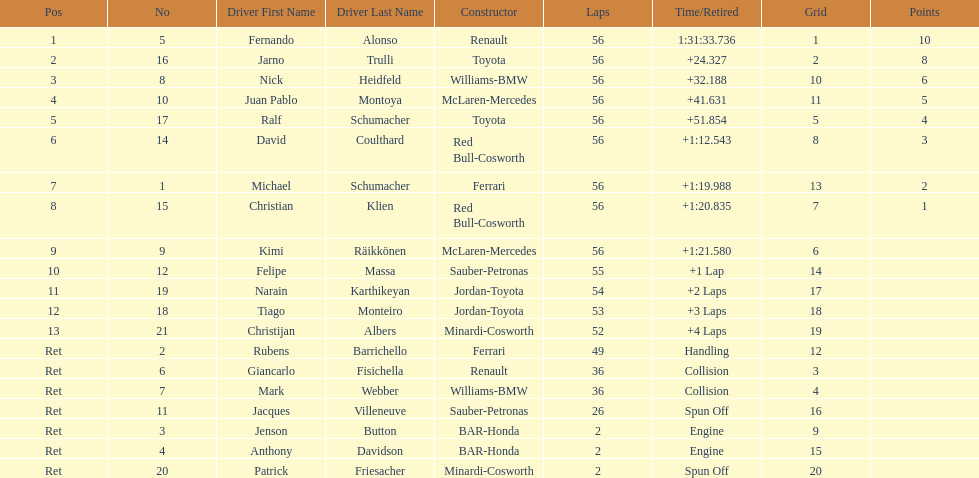How long did it take fernando alonso to finish the race? 1:31:33.736. 